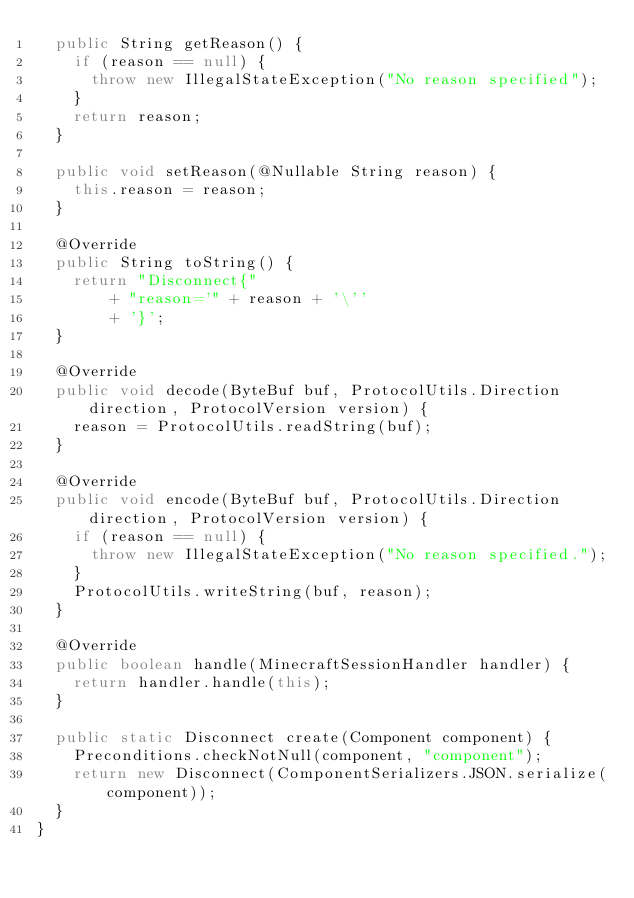Convert code to text. <code><loc_0><loc_0><loc_500><loc_500><_Java_>  public String getReason() {
    if (reason == null) {
      throw new IllegalStateException("No reason specified");
    }
    return reason;
  }

  public void setReason(@Nullable String reason) {
    this.reason = reason;
  }

  @Override
  public String toString() {
    return "Disconnect{"
        + "reason='" + reason + '\''
        + '}';
  }

  @Override
  public void decode(ByteBuf buf, ProtocolUtils.Direction direction, ProtocolVersion version) {
    reason = ProtocolUtils.readString(buf);
  }

  @Override
  public void encode(ByteBuf buf, ProtocolUtils.Direction direction, ProtocolVersion version) {
    if (reason == null) {
      throw new IllegalStateException("No reason specified.");
    }
    ProtocolUtils.writeString(buf, reason);
  }

  @Override
  public boolean handle(MinecraftSessionHandler handler) {
    return handler.handle(this);
  }

  public static Disconnect create(Component component) {
    Preconditions.checkNotNull(component, "component");
    return new Disconnect(ComponentSerializers.JSON.serialize(component));
  }
}
</code> 